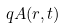Convert formula to latex. <formula><loc_0><loc_0><loc_500><loc_500>q A ( r , t )</formula> 